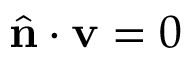Convert formula to latex. <formula><loc_0><loc_0><loc_500><loc_500>\hat { n } \cdot v = 0</formula> 